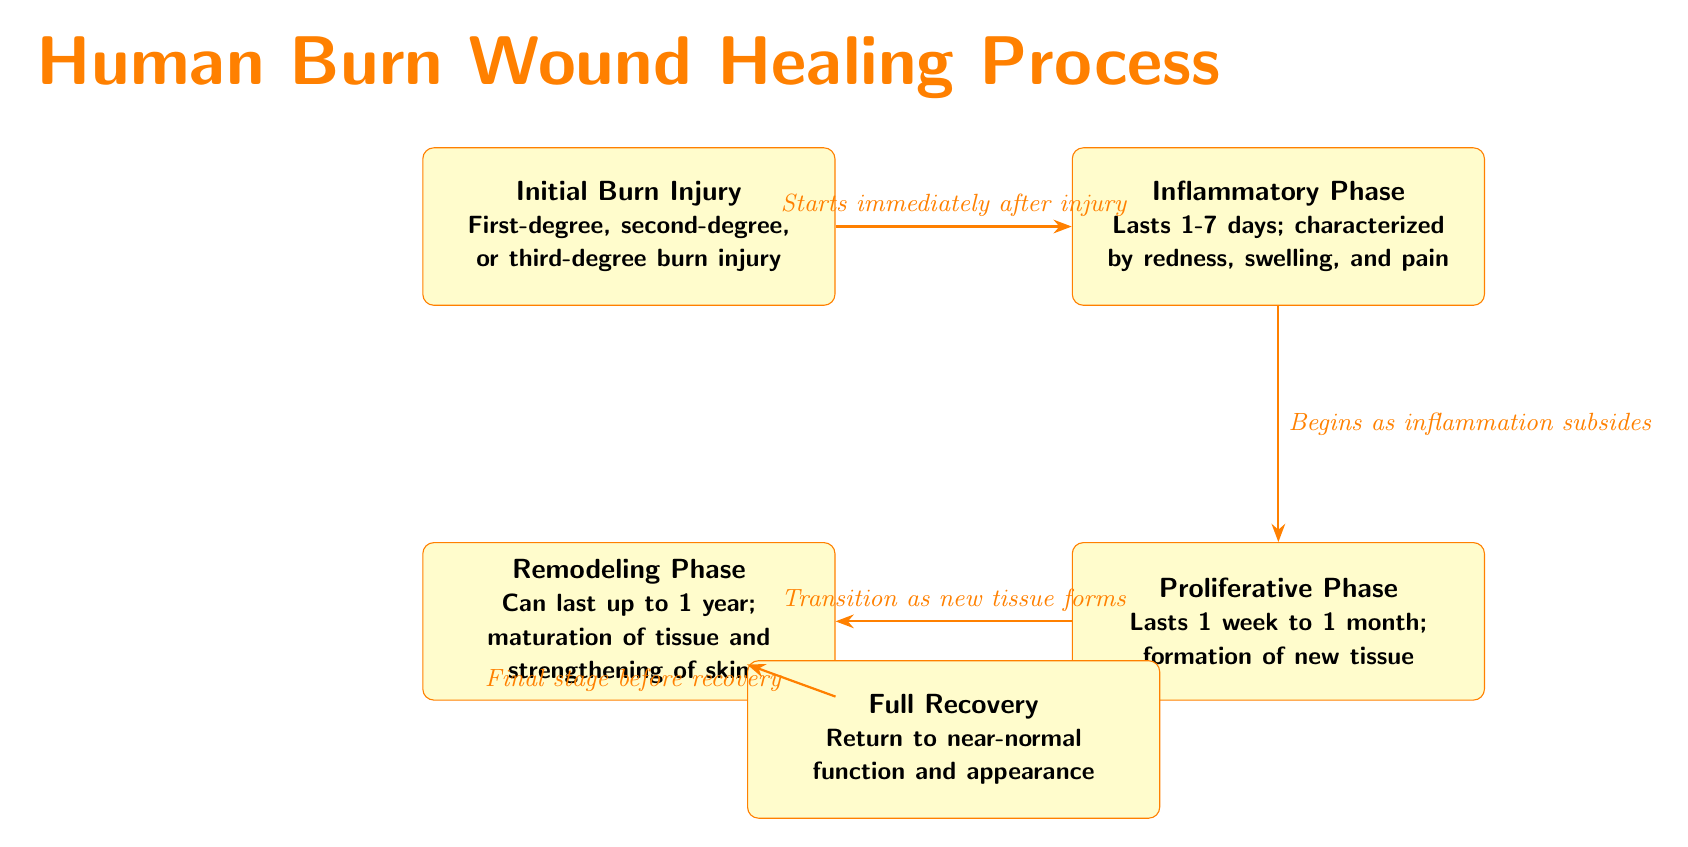What is the first stage of the burn healing process? The diagram indicates that the first stage of the burn healing process is "Initial Burn Injury", which describes the types of burn (first-degree, second-degree, or third-degree) suffered.
Answer: Initial Burn Injury How many main stages are there in the burn healing process? By counting the nodes labeled in the diagram, we see there are five main stages listed: Initial Burn Injury, Inflammatory Phase, Proliferative Phase, Remodeling Phase, and Full Recovery.
Answer: 5 What characterizes the Inflammatory Phase? The diagram specifies that the Inflammatory Phase lasts 1-7 days and is characterized by redness, swelling, and pain. This is evident from the description contained in the node labeled "Inflammatory Phase."
Answer: Redness, swelling, and pain What follows the Inflammatory Phase? The diagram shows that the "Proliferative Phase" follows the Inflammatory Phase, as denoted by the arrow leading from the Inflammatory Phase node to the Proliferative Phase node.
Answer: Proliferative Phase What phase occurs before the Full Recovery stage? According to the diagram, the "Remodeling Phase" occurs before the Full Recovery stage, as indicated by the connecting arrow from the Remodeling Phase to the Full Recovery node.
Answer: Remodeling Phase How long does the Remodeling Phase last? Upon looking at the description in the "Remodeling Phase" node of the diagram, it states that this phase can last up to 1 year.
Answer: Up to 1 year What does the diagram state happens as inflammation subsides? The diagram indicates that "Proliferative Phase" begins as inflammation subsides, which is noted in the context connecting the two phases.
Answer: Proliferative Phase What is the relationship between the Initial Burn Injury and Full Recovery? Analyzing the flow in the diagram, the path shows a progression from Initial Burn Injury through various stages that ultimately lead to Full Recovery, indicating a process of healing.
Answer: Progressive healing process What is the last stage in the burn wound healing process? The diagram clearly states that the last stage in the burn wound healing process is "Full Recovery," which signifies the endpoint of the healing timeline.
Answer: Full Recovery 